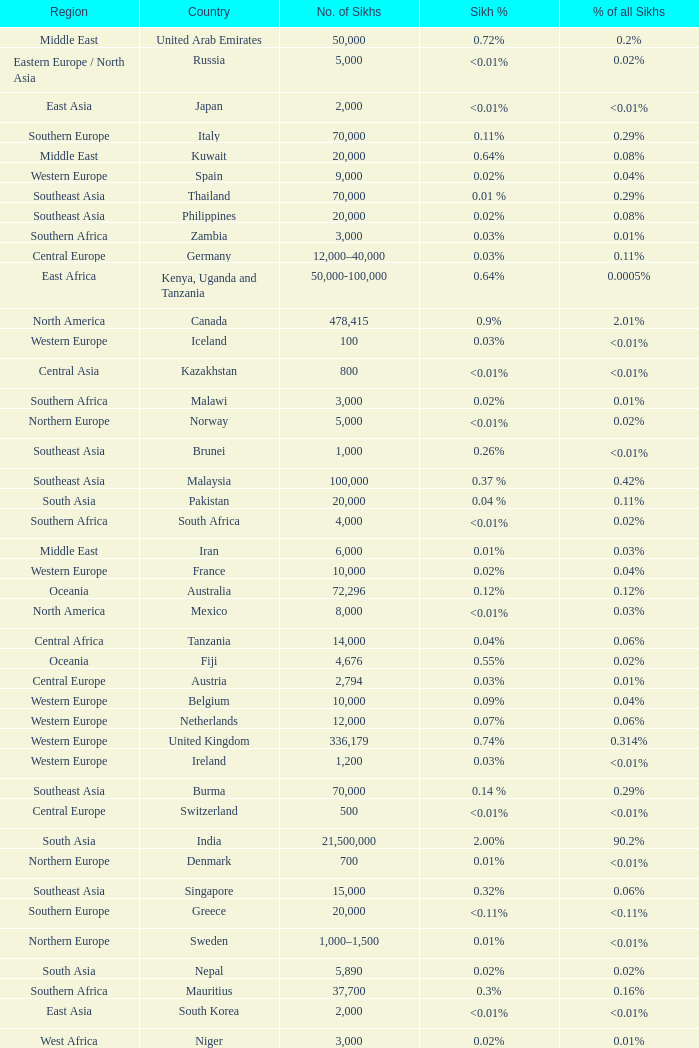What is the number of sikhs in Japan? 2000.0. 